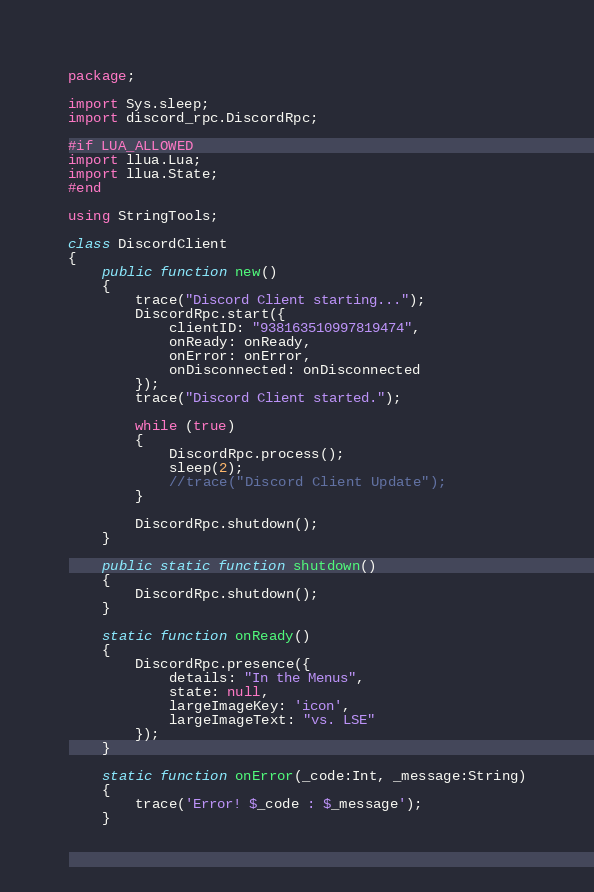<code> <loc_0><loc_0><loc_500><loc_500><_Haxe_>package;

import Sys.sleep;
import discord_rpc.DiscordRpc;

#if LUA_ALLOWED
import llua.Lua;
import llua.State;
#end

using StringTools;

class DiscordClient
{
	public function new()
	{
		trace("Discord Client starting...");
		DiscordRpc.start({
			clientID: "938163510997819474",
			onReady: onReady,
			onError: onError,
			onDisconnected: onDisconnected
		});
		trace("Discord Client started.");

		while (true)
		{
			DiscordRpc.process();
			sleep(2);
			//trace("Discord Client Update");
		}

		DiscordRpc.shutdown();
	}
	
	public static function shutdown()
	{
		DiscordRpc.shutdown();
	}
	
	static function onReady()
	{
		DiscordRpc.presence({
			details: "In the Menus",
			state: null,
			largeImageKey: 'icon',
			largeImageText: "vs. LSE"
		});
	}

	static function onError(_code:Int, _message:String)
	{
		trace('Error! $_code : $_message');
	}
</code> 